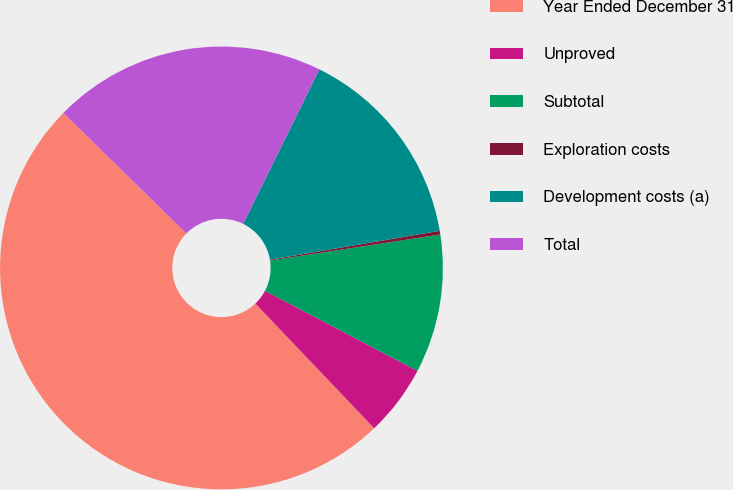Convert chart. <chart><loc_0><loc_0><loc_500><loc_500><pie_chart><fcel>Year Ended December 31<fcel>Unproved<fcel>Subtotal<fcel>Exploration costs<fcel>Development costs (a)<fcel>Total<nl><fcel>49.46%<fcel>5.19%<fcel>10.11%<fcel>0.27%<fcel>15.03%<fcel>19.95%<nl></chart> 